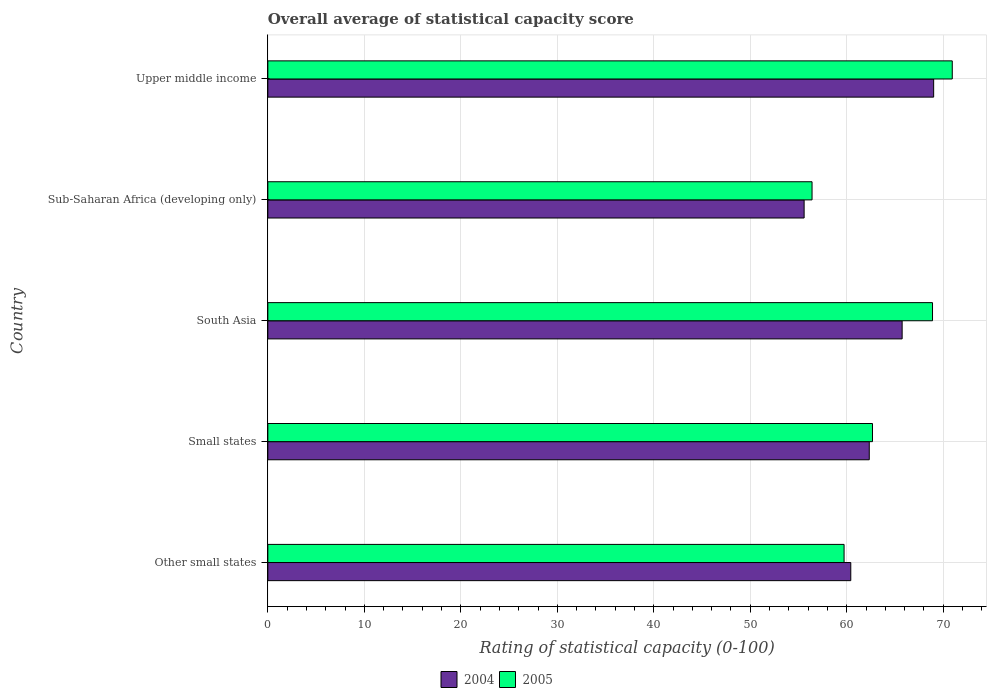Are the number of bars on each tick of the Y-axis equal?
Provide a succinct answer. Yes. How many bars are there on the 3rd tick from the top?
Provide a short and direct response. 2. How many bars are there on the 1st tick from the bottom?
Offer a very short reply. 2. In how many cases, is the number of bars for a given country not equal to the number of legend labels?
Make the answer very short. 0. What is the rating of statistical capacity in 2005 in Small states?
Make the answer very short. 62.67. Across all countries, what is the maximum rating of statistical capacity in 2005?
Your response must be concise. 70.94. Across all countries, what is the minimum rating of statistical capacity in 2005?
Keep it short and to the point. 56.4. In which country was the rating of statistical capacity in 2004 maximum?
Provide a short and direct response. Upper middle income. In which country was the rating of statistical capacity in 2005 minimum?
Ensure brevity in your answer.  Sub-Saharan Africa (developing only). What is the total rating of statistical capacity in 2004 in the graph?
Provide a short and direct response. 313.08. What is the difference between the rating of statistical capacity in 2005 in Other small states and that in Small states?
Keep it short and to the point. -2.94. What is the difference between the rating of statistical capacity in 2004 in South Asia and the rating of statistical capacity in 2005 in Sub-Saharan Africa (developing only)?
Offer a very short reply. 9.34. What is the average rating of statistical capacity in 2004 per country?
Provide a short and direct response. 62.62. What is the difference between the rating of statistical capacity in 2005 and rating of statistical capacity in 2004 in Upper middle income?
Your answer should be compact. 1.93. What is the ratio of the rating of statistical capacity in 2004 in Other small states to that in Small states?
Your answer should be very brief. 0.97. What is the difference between the highest and the second highest rating of statistical capacity in 2004?
Keep it short and to the point. 3.27. What is the difference between the highest and the lowest rating of statistical capacity in 2004?
Give a very brief answer. 13.42. In how many countries, is the rating of statistical capacity in 2004 greater than the average rating of statistical capacity in 2004 taken over all countries?
Make the answer very short. 2. Is the sum of the rating of statistical capacity in 2005 in Sub-Saharan Africa (developing only) and Upper middle income greater than the maximum rating of statistical capacity in 2004 across all countries?
Your response must be concise. Yes. How many bars are there?
Provide a short and direct response. 10. What is the difference between two consecutive major ticks on the X-axis?
Provide a short and direct response. 10. Does the graph contain any zero values?
Make the answer very short. No. Does the graph contain grids?
Offer a terse response. Yes. Where does the legend appear in the graph?
Provide a short and direct response. Bottom center. How are the legend labels stacked?
Make the answer very short. Horizontal. What is the title of the graph?
Give a very brief answer. Overall average of statistical capacity score. Does "1994" appear as one of the legend labels in the graph?
Offer a very short reply. No. What is the label or title of the X-axis?
Provide a succinct answer. Rating of statistical capacity (0-100). What is the Rating of statistical capacity (0-100) of 2004 in Other small states?
Make the answer very short. 60.42. What is the Rating of statistical capacity (0-100) in 2005 in Other small states?
Your answer should be very brief. 59.72. What is the Rating of statistical capacity (0-100) in 2004 in Small states?
Give a very brief answer. 62.33. What is the Rating of statistical capacity (0-100) of 2005 in Small states?
Provide a short and direct response. 62.67. What is the Rating of statistical capacity (0-100) in 2004 in South Asia?
Provide a short and direct response. 65.74. What is the Rating of statistical capacity (0-100) in 2005 in South Asia?
Offer a very short reply. 68.89. What is the Rating of statistical capacity (0-100) of 2004 in Sub-Saharan Africa (developing only)?
Offer a terse response. 55.58. What is the Rating of statistical capacity (0-100) of 2005 in Sub-Saharan Africa (developing only)?
Provide a succinct answer. 56.4. What is the Rating of statistical capacity (0-100) in 2004 in Upper middle income?
Provide a short and direct response. 69.01. What is the Rating of statistical capacity (0-100) in 2005 in Upper middle income?
Provide a short and direct response. 70.94. Across all countries, what is the maximum Rating of statistical capacity (0-100) of 2004?
Make the answer very short. 69.01. Across all countries, what is the maximum Rating of statistical capacity (0-100) of 2005?
Your answer should be very brief. 70.94. Across all countries, what is the minimum Rating of statistical capacity (0-100) of 2004?
Your answer should be very brief. 55.58. Across all countries, what is the minimum Rating of statistical capacity (0-100) in 2005?
Your response must be concise. 56.4. What is the total Rating of statistical capacity (0-100) in 2004 in the graph?
Offer a terse response. 313.08. What is the total Rating of statistical capacity (0-100) of 2005 in the graph?
Your answer should be very brief. 318.62. What is the difference between the Rating of statistical capacity (0-100) of 2004 in Other small states and that in Small states?
Give a very brief answer. -1.92. What is the difference between the Rating of statistical capacity (0-100) in 2005 in Other small states and that in Small states?
Ensure brevity in your answer.  -2.94. What is the difference between the Rating of statistical capacity (0-100) in 2004 in Other small states and that in South Asia?
Ensure brevity in your answer.  -5.32. What is the difference between the Rating of statistical capacity (0-100) of 2005 in Other small states and that in South Asia?
Ensure brevity in your answer.  -9.17. What is the difference between the Rating of statistical capacity (0-100) in 2004 in Other small states and that in Sub-Saharan Africa (developing only)?
Your answer should be compact. 4.83. What is the difference between the Rating of statistical capacity (0-100) of 2005 in Other small states and that in Sub-Saharan Africa (developing only)?
Provide a short and direct response. 3.32. What is the difference between the Rating of statistical capacity (0-100) of 2004 in Other small states and that in Upper middle income?
Give a very brief answer. -8.59. What is the difference between the Rating of statistical capacity (0-100) of 2005 in Other small states and that in Upper middle income?
Give a very brief answer. -11.21. What is the difference between the Rating of statistical capacity (0-100) in 2004 in Small states and that in South Asia?
Make the answer very short. -3.41. What is the difference between the Rating of statistical capacity (0-100) in 2005 in Small states and that in South Asia?
Your answer should be compact. -6.22. What is the difference between the Rating of statistical capacity (0-100) of 2004 in Small states and that in Sub-Saharan Africa (developing only)?
Offer a very short reply. 6.75. What is the difference between the Rating of statistical capacity (0-100) in 2005 in Small states and that in Sub-Saharan Africa (developing only)?
Make the answer very short. 6.26. What is the difference between the Rating of statistical capacity (0-100) in 2004 in Small states and that in Upper middle income?
Provide a short and direct response. -6.67. What is the difference between the Rating of statistical capacity (0-100) in 2005 in Small states and that in Upper middle income?
Give a very brief answer. -8.27. What is the difference between the Rating of statistical capacity (0-100) of 2004 in South Asia and that in Sub-Saharan Africa (developing only)?
Your response must be concise. 10.16. What is the difference between the Rating of statistical capacity (0-100) of 2005 in South Asia and that in Sub-Saharan Africa (developing only)?
Your answer should be very brief. 12.49. What is the difference between the Rating of statistical capacity (0-100) of 2004 in South Asia and that in Upper middle income?
Provide a short and direct response. -3.27. What is the difference between the Rating of statistical capacity (0-100) in 2005 in South Asia and that in Upper middle income?
Make the answer very short. -2.05. What is the difference between the Rating of statistical capacity (0-100) of 2004 in Sub-Saharan Africa (developing only) and that in Upper middle income?
Keep it short and to the point. -13.42. What is the difference between the Rating of statistical capacity (0-100) of 2005 in Sub-Saharan Africa (developing only) and that in Upper middle income?
Ensure brevity in your answer.  -14.53. What is the difference between the Rating of statistical capacity (0-100) of 2004 in Other small states and the Rating of statistical capacity (0-100) of 2005 in Small states?
Offer a very short reply. -2.25. What is the difference between the Rating of statistical capacity (0-100) in 2004 in Other small states and the Rating of statistical capacity (0-100) in 2005 in South Asia?
Provide a short and direct response. -8.47. What is the difference between the Rating of statistical capacity (0-100) of 2004 in Other small states and the Rating of statistical capacity (0-100) of 2005 in Sub-Saharan Africa (developing only)?
Your answer should be very brief. 4.01. What is the difference between the Rating of statistical capacity (0-100) of 2004 in Other small states and the Rating of statistical capacity (0-100) of 2005 in Upper middle income?
Provide a short and direct response. -10.52. What is the difference between the Rating of statistical capacity (0-100) of 2004 in Small states and the Rating of statistical capacity (0-100) of 2005 in South Asia?
Provide a succinct answer. -6.56. What is the difference between the Rating of statistical capacity (0-100) in 2004 in Small states and the Rating of statistical capacity (0-100) in 2005 in Sub-Saharan Africa (developing only)?
Provide a short and direct response. 5.93. What is the difference between the Rating of statistical capacity (0-100) in 2004 in Small states and the Rating of statistical capacity (0-100) in 2005 in Upper middle income?
Give a very brief answer. -8.6. What is the difference between the Rating of statistical capacity (0-100) in 2004 in South Asia and the Rating of statistical capacity (0-100) in 2005 in Sub-Saharan Africa (developing only)?
Offer a very short reply. 9.34. What is the difference between the Rating of statistical capacity (0-100) of 2004 in South Asia and the Rating of statistical capacity (0-100) of 2005 in Upper middle income?
Offer a very short reply. -5.19. What is the difference between the Rating of statistical capacity (0-100) in 2004 in Sub-Saharan Africa (developing only) and the Rating of statistical capacity (0-100) in 2005 in Upper middle income?
Your answer should be compact. -15.35. What is the average Rating of statistical capacity (0-100) in 2004 per country?
Keep it short and to the point. 62.62. What is the average Rating of statistical capacity (0-100) in 2005 per country?
Keep it short and to the point. 63.72. What is the difference between the Rating of statistical capacity (0-100) in 2004 and Rating of statistical capacity (0-100) in 2005 in Other small states?
Your answer should be compact. 0.69. What is the difference between the Rating of statistical capacity (0-100) of 2004 and Rating of statistical capacity (0-100) of 2005 in South Asia?
Offer a very short reply. -3.15. What is the difference between the Rating of statistical capacity (0-100) of 2004 and Rating of statistical capacity (0-100) of 2005 in Sub-Saharan Africa (developing only)?
Offer a very short reply. -0.82. What is the difference between the Rating of statistical capacity (0-100) in 2004 and Rating of statistical capacity (0-100) in 2005 in Upper middle income?
Your response must be concise. -1.93. What is the ratio of the Rating of statistical capacity (0-100) in 2004 in Other small states to that in Small states?
Your response must be concise. 0.97. What is the ratio of the Rating of statistical capacity (0-100) of 2005 in Other small states to that in Small states?
Give a very brief answer. 0.95. What is the ratio of the Rating of statistical capacity (0-100) of 2004 in Other small states to that in South Asia?
Provide a succinct answer. 0.92. What is the ratio of the Rating of statistical capacity (0-100) of 2005 in Other small states to that in South Asia?
Provide a succinct answer. 0.87. What is the ratio of the Rating of statistical capacity (0-100) in 2004 in Other small states to that in Sub-Saharan Africa (developing only)?
Your answer should be compact. 1.09. What is the ratio of the Rating of statistical capacity (0-100) of 2005 in Other small states to that in Sub-Saharan Africa (developing only)?
Your answer should be very brief. 1.06. What is the ratio of the Rating of statistical capacity (0-100) of 2004 in Other small states to that in Upper middle income?
Offer a terse response. 0.88. What is the ratio of the Rating of statistical capacity (0-100) in 2005 in Other small states to that in Upper middle income?
Make the answer very short. 0.84. What is the ratio of the Rating of statistical capacity (0-100) of 2004 in Small states to that in South Asia?
Provide a succinct answer. 0.95. What is the ratio of the Rating of statistical capacity (0-100) in 2005 in Small states to that in South Asia?
Offer a very short reply. 0.91. What is the ratio of the Rating of statistical capacity (0-100) in 2004 in Small states to that in Sub-Saharan Africa (developing only)?
Your answer should be compact. 1.12. What is the ratio of the Rating of statistical capacity (0-100) in 2004 in Small states to that in Upper middle income?
Offer a very short reply. 0.9. What is the ratio of the Rating of statistical capacity (0-100) in 2005 in Small states to that in Upper middle income?
Your answer should be compact. 0.88. What is the ratio of the Rating of statistical capacity (0-100) of 2004 in South Asia to that in Sub-Saharan Africa (developing only)?
Your response must be concise. 1.18. What is the ratio of the Rating of statistical capacity (0-100) in 2005 in South Asia to that in Sub-Saharan Africa (developing only)?
Your answer should be compact. 1.22. What is the ratio of the Rating of statistical capacity (0-100) of 2004 in South Asia to that in Upper middle income?
Make the answer very short. 0.95. What is the ratio of the Rating of statistical capacity (0-100) in 2005 in South Asia to that in Upper middle income?
Offer a terse response. 0.97. What is the ratio of the Rating of statistical capacity (0-100) in 2004 in Sub-Saharan Africa (developing only) to that in Upper middle income?
Give a very brief answer. 0.81. What is the ratio of the Rating of statistical capacity (0-100) in 2005 in Sub-Saharan Africa (developing only) to that in Upper middle income?
Offer a terse response. 0.8. What is the difference between the highest and the second highest Rating of statistical capacity (0-100) in 2004?
Offer a terse response. 3.27. What is the difference between the highest and the second highest Rating of statistical capacity (0-100) of 2005?
Offer a very short reply. 2.05. What is the difference between the highest and the lowest Rating of statistical capacity (0-100) in 2004?
Ensure brevity in your answer.  13.42. What is the difference between the highest and the lowest Rating of statistical capacity (0-100) of 2005?
Make the answer very short. 14.53. 